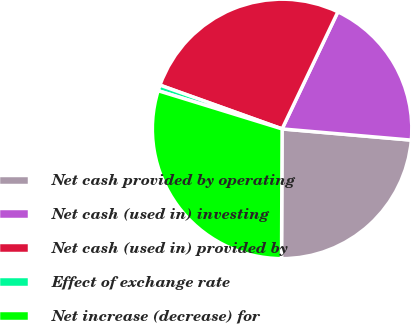<chart> <loc_0><loc_0><loc_500><loc_500><pie_chart><fcel>Net cash provided by operating<fcel>Net cash (used in) investing<fcel>Net cash (used in) provided by<fcel>Effect of exchange rate<fcel>Net increase (decrease) for<nl><fcel>23.7%<fcel>19.3%<fcel>26.6%<fcel>0.72%<fcel>29.69%<nl></chart> 